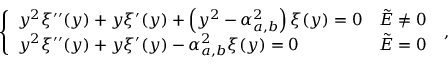Convert formula to latex. <formula><loc_0><loc_0><loc_500><loc_500>\left \{ \begin{array} { l l } { y ^ { 2 } \xi ^ { \prime \prime } ( y ) + y \xi ^ { \prime } ( y ) + \left ( y ^ { 2 } - \alpha _ { a , b } ^ { 2 } \right ) \xi ( y ) = 0 } & { \tilde { E } \neq 0 } \\ { y ^ { 2 } \xi ^ { \prime \prime } ( y ) + y \xi ^ { \prime } ( y ) - \alpha _ { a , b } ^ { 2 } \xi ( y ) = 0 } & { \tilde { E } = 0 } \end{array} \, ,</formula> 